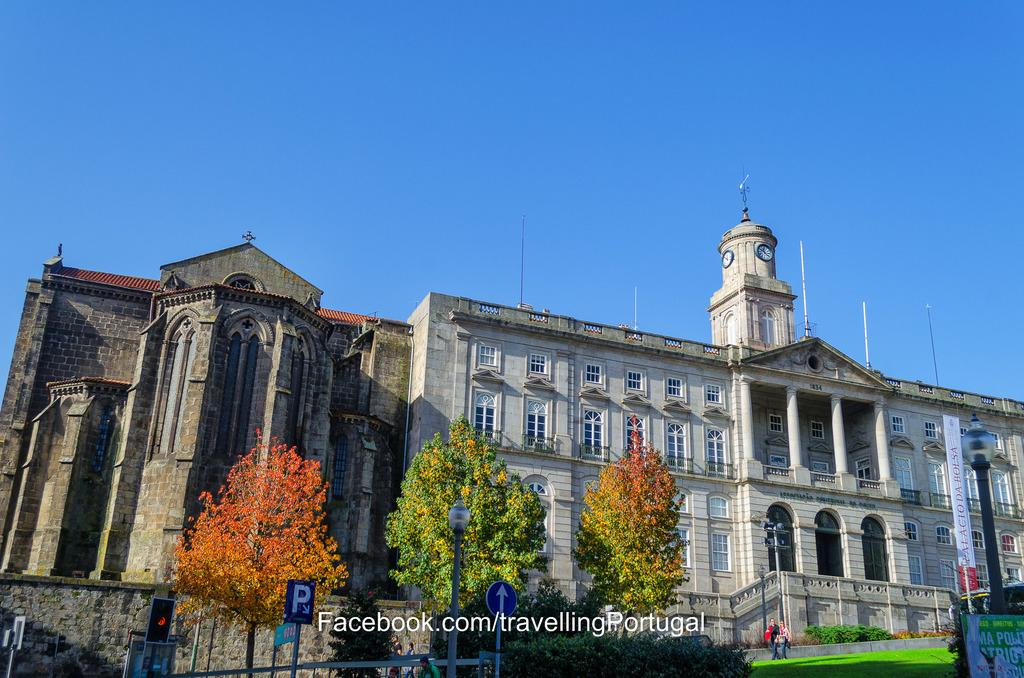<image>
Present a compact description of the photo's key features. A historic building in the sunshine in Portugal. 